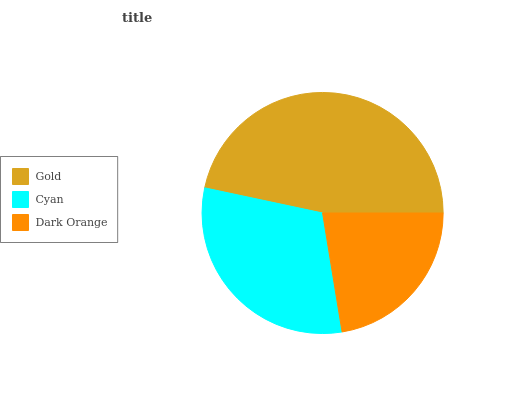Is Dark Orange the minimum?
Answer yes or no. Yes. Is Gold the maximum?
Answer yes or no. Yes. Is Cyan the minimum?
Answer yes or no. No. Is Cyan the maximum?
Answer yes or no. No. Is Gold greater than Cyan?
Answer yes or no. Yes. Is Cyan less than Gold?
Answer yes or no. Yes. Is Cyan greater than Gold?
Answer yes or no. No. Is Gold less than Cyan?
Answer yes or no. No. Is Cyan the high median?
Answer yes or no. Yes. Is Cyan the low median?
Answer yes or no. Yes. Is Dark Orange the high median?
Answer yes or no. No. Is Gold the low median?
Answer yes or no. No. 